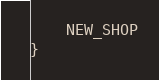<code> <loc_0><loc_0><loc_500><loc_500><_Kotlin_>    NEW_SHOP
}</code> 